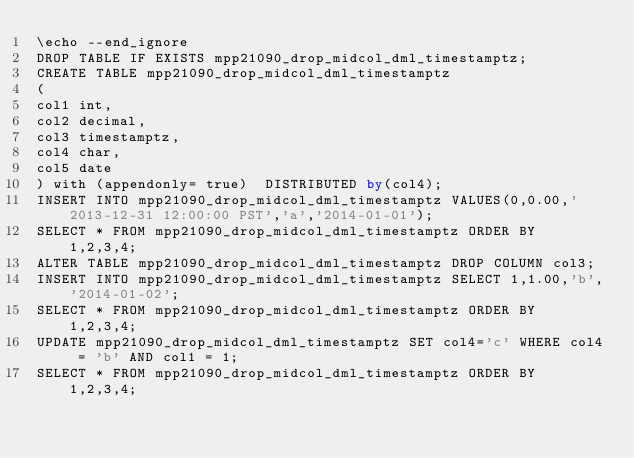Convert code to text. <code><loc_0><loc_0><loc_500><loc_500><_SQL_>\echo --end_ignore
DROP TABLE IF EXISTS mpp21090_drop_midcol_dml_timestamptz;
CREATE TABLE mpp21090_drop_midcol_dml_timestamptz
(
col1 int,
col2 decimal,
col3 timestamptz,
col4 char,
col5 date
) with (appendonly= true)  DISTRIBUTED by(col4);
INSERT INTO mpp21090_drop_midcol_dml_timestamptz VALUES(0,0.00,'2013-12-31 12:00:00 PST','a','2014-01-01');
SELECT * FROM mpp21090_drop_midcol_dml_timestamptz ORDER BY 1,2,3,4;
ALTER TABLE mpp21090_drop_midcol_dml_timestamptz DROP COLUMN col3;
INSERT INTO mpp21090_drop_midcol_dml_timestamptz SELECT 1,1.00,'b','2014-01-02';
SELECT * FROM mpp21090_drop_midcol_dml_timestamptz ORDER BY 1,2,3,4;
UPDATE mpp21090_drop_midcol_dml_timestamptz SET col4='c' WHERE col4 = 'b' AND col1 = 1;
SELECT * FROM mpp21090_drop_midcol_dml_timestamptz ORDER BY 1,2,3,4;
</code> 